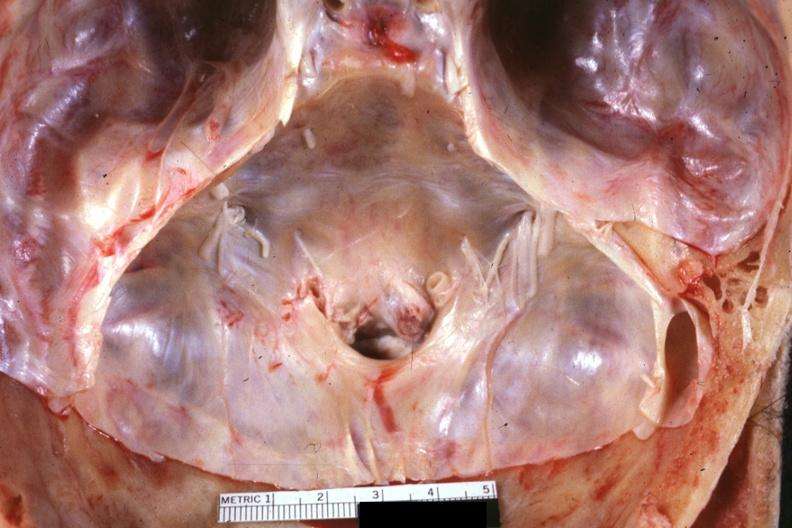s carcinomatosis endometrium primary present?
Answer the question using a single word or phrase. No 